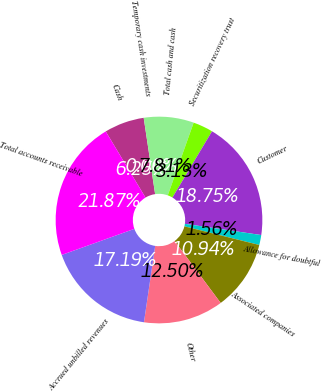Convert chart. <chart><loc_0><loc_0><loc_500><loc_500><pie_chart><fcel>Cash<fcel>Temporary cash investments<fcel>Total cash and cash<fcel>Securitization recovery trust<fcel>Customer<fcel>Allowance for doubtful<fcel>Associated companies<fcel>Other<fcel>Accrued unbilled revenues<fcel>Total accounts receivable<nl><fcel>6.25%<fcel>0.0%<fcel>7.81%<fcel>3.13%<fcel>18.75%<fcel>1.56%<fcel>10.94%<fcel>12.5%<fcel>17.19%<fcel>21.87%<nl></chart> 